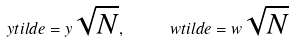Convert formula to latex. <formula><loc_0><loc_0><loc_500><loc_500>\ y t i l d e = y \sqrt { N } , \quad \ \ w t i l d e = w \sqrt { N }</formula> 